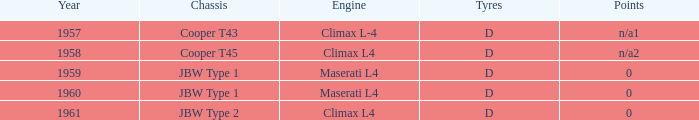What firm was responsible for creating the chassis in 1960 with a climax l4 engine? JBW Type 2. 